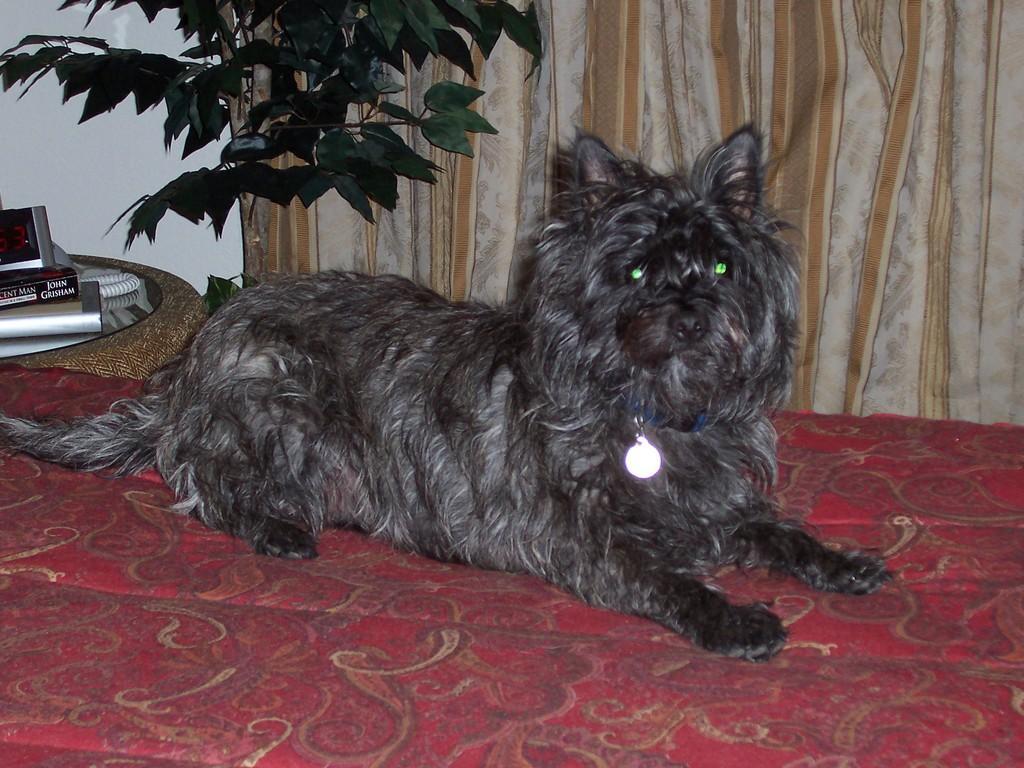Describe this image in one or two sentences. In this image I can see a dog which is black and cream in color is laying on the red and brown colored surface. I can see a blue colored belt to its neck. In the background I can see a plant which is green in color, the curtain which is cream and brown in color, a telephone and few other objects on the table. 